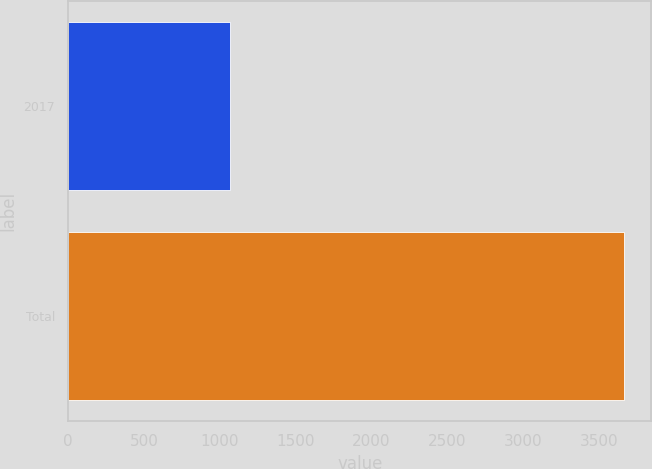Convert chart to OTSL. <chart><loc_0><loc_0><loc_500><loc_500><bar_chart><fcel>2017<fcel>Total<nl><fcel>1064<fcel>3662<nl></chart> 